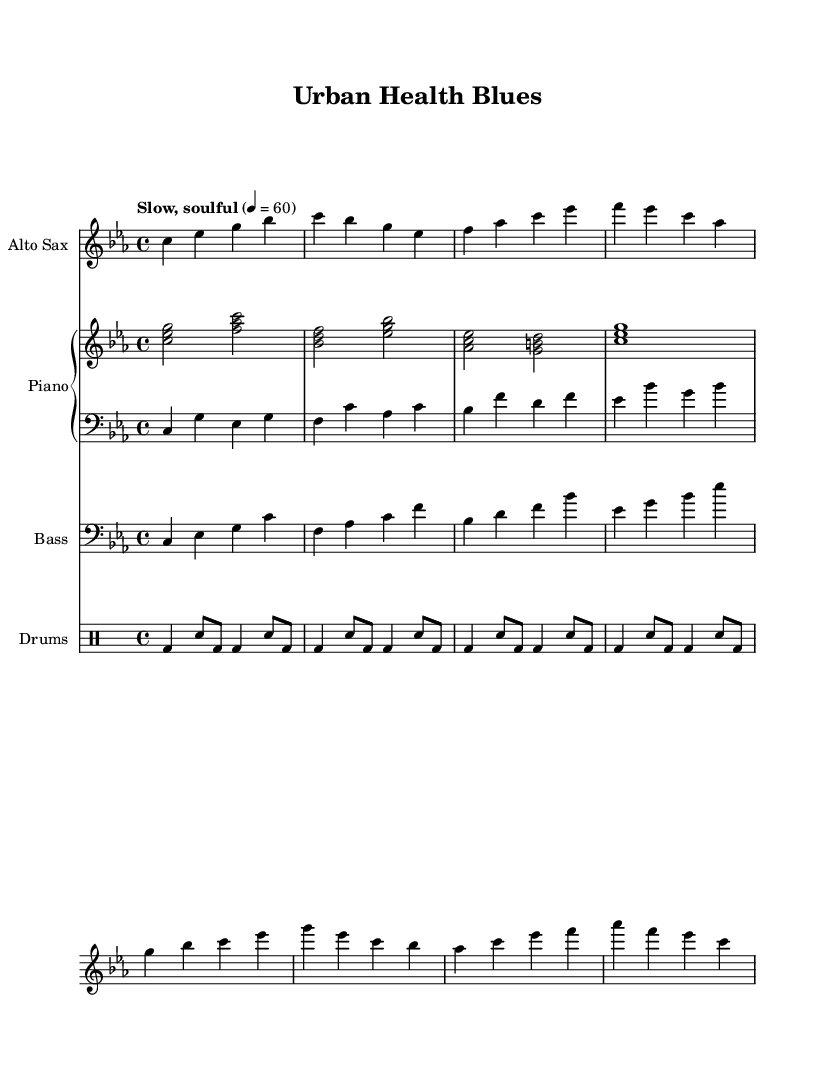What is the key signature of this music? The key signature indicates C minor based on the presence of three flats (B, E, and A) shown at the beginning of the music staff.
Answer: C minor What is the time signature of this composition? The time signature is 4/4, as indicated at the beginning of the score with a '4' above and below the staff, signifying four beats per measure.
Answer: 4/4 What is the tempo marking for this piece? The tempo marking "Slow, soulful" specifies the emotional style and pacing, with a metronome of 60 beats per minute indicating slow tempos.
Answer: Slow, soulful How many measures are there in the saxophone part? By counting the groups of notes in the saxophone section, we observe there are eight measures in total.
Answer: 8 What chords are used in the piano part? The chords in the right hand of the piano are C minor, F major, B flat major, E flat major chords, which are typical for jazz compositions.
Answer: C minor, F major, B flat major, E flat major Which instrument plays the solo melody in the piece? The score indicates that the melody is played by the Alto Saxophone, as it is the only part with a distinct melodic line in the treble clef.
Answer: Alto Saxophone What rhythmic pattern is predominant in the drum part? Analyzing the drum part reveals a consistent bass drum and snare drum pattern, where the bass drum appears on each primary beat and the snare on the second and fourth.
Answer: Bass drum and snare 